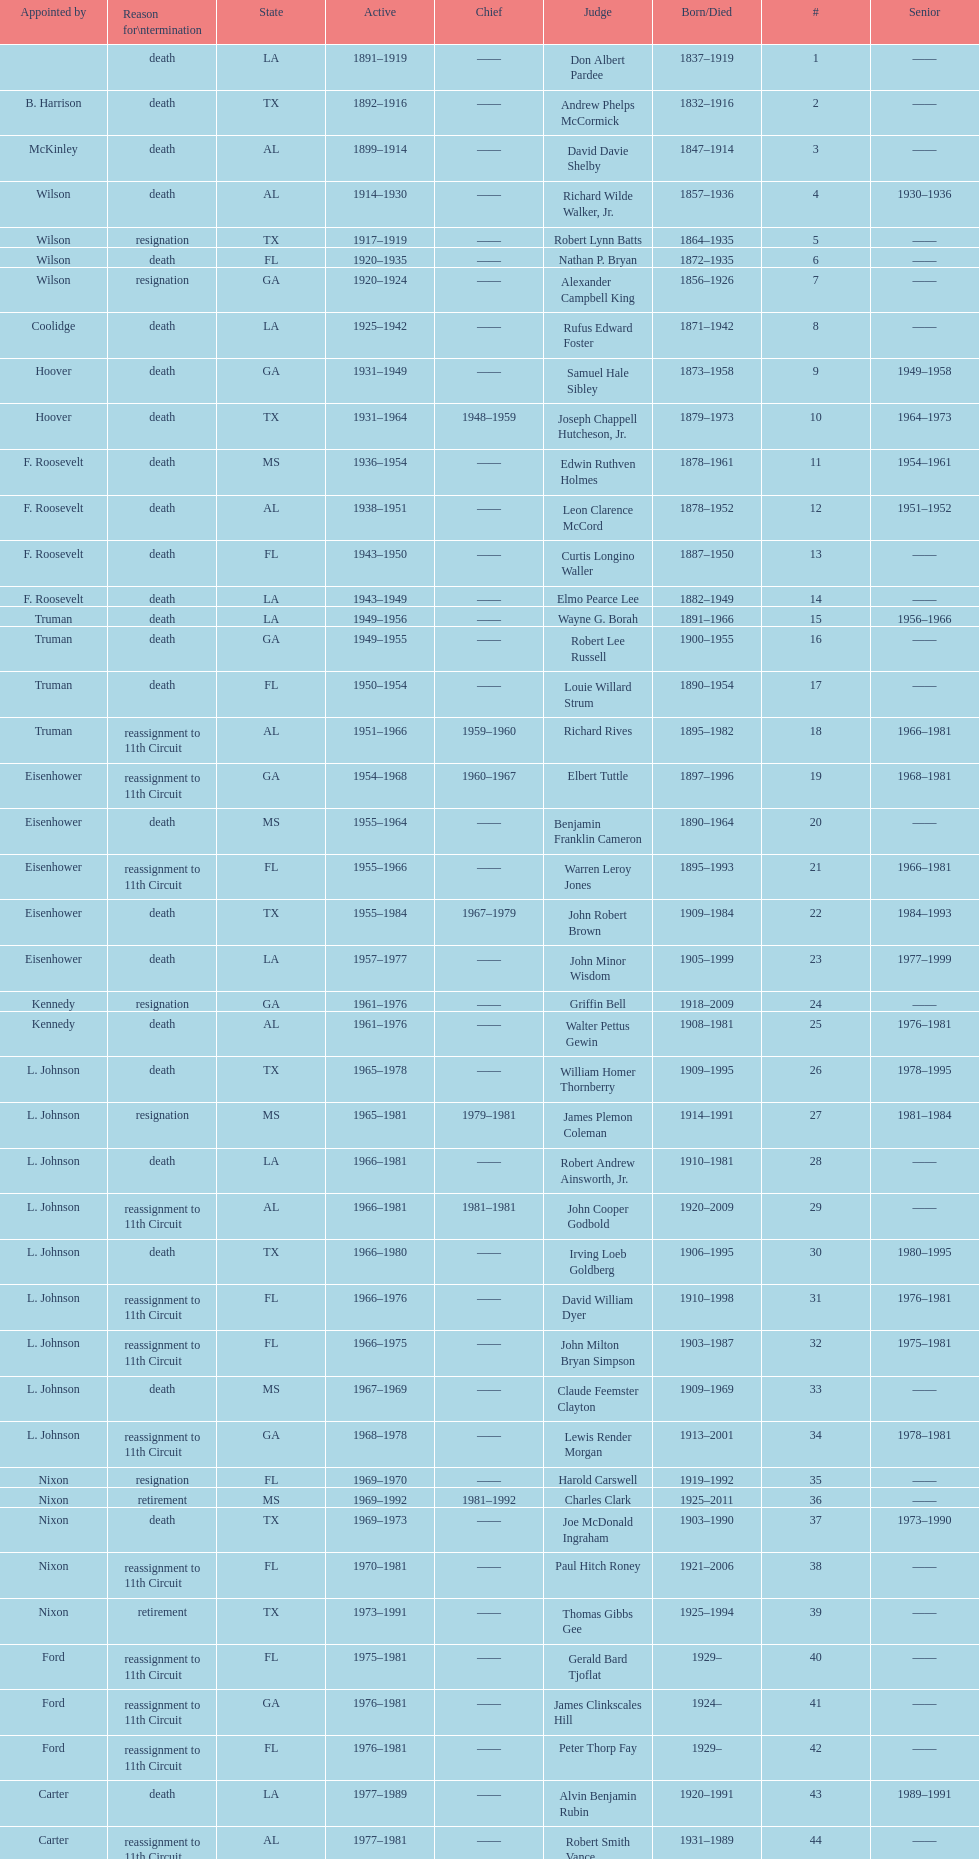Which state has the largest amount of judges to serve? TX. 